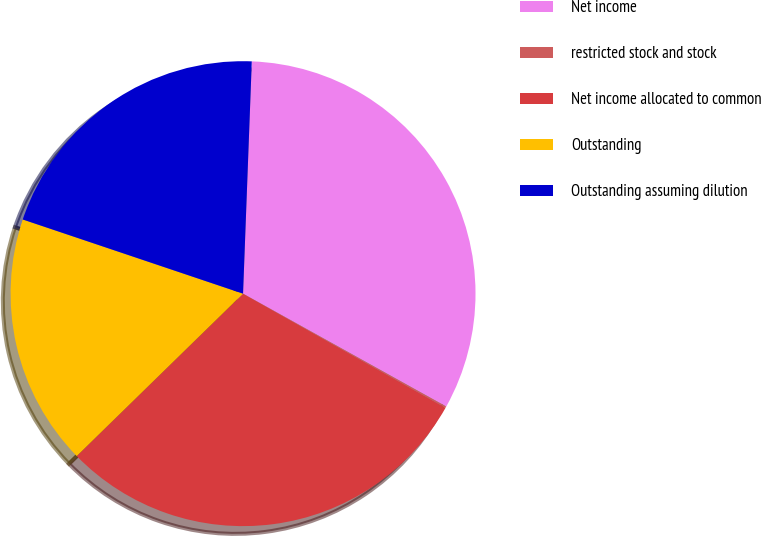Convert chart. <chart><loc_0><loc_0><loc_500><loc_500><pie_chart><fcel>Net income<fcel>restricted stock and stock<fcel>Net income allocated to common<fcel>Outstanding<fcel>Outstanding assuming dilution<nl><fcel>32.47%<fcel>0.1%<fcel>29.52%<fcel>17.48%<fcel>20.43%<nl></chart> 